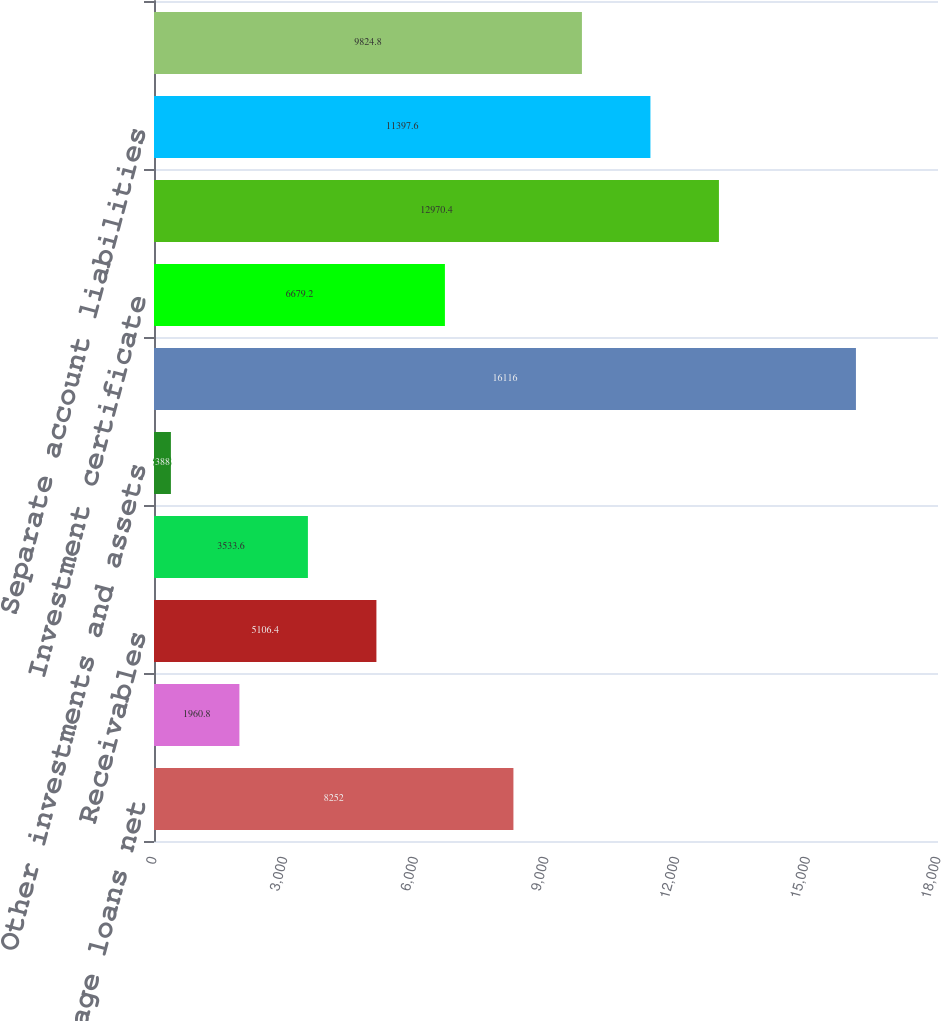Convert chart. <chart><loc_0><loc_0><loc_500><loc_500><bar_chart><fcel>Commercial mortgage loans net<fcel>Policy loans<fcel>Receivables<fcel>Restricted and segregated cash<fcel>Other investments and assets<fcel>Future policy benefits and<fcel>Investment certificate<fcel>Banking and brokerage customer<fcel>Separate account liabilities<fcel>Debt and other liabilities<nl><fcel>8252<fcel>1960.8<fcel>5106.4<fcel>3533.6<fcel>388<fcel>16116<fcel>6679.2<fcel>12970.4<fcel>11397.6<fcel>9824.8<nl></chart> 